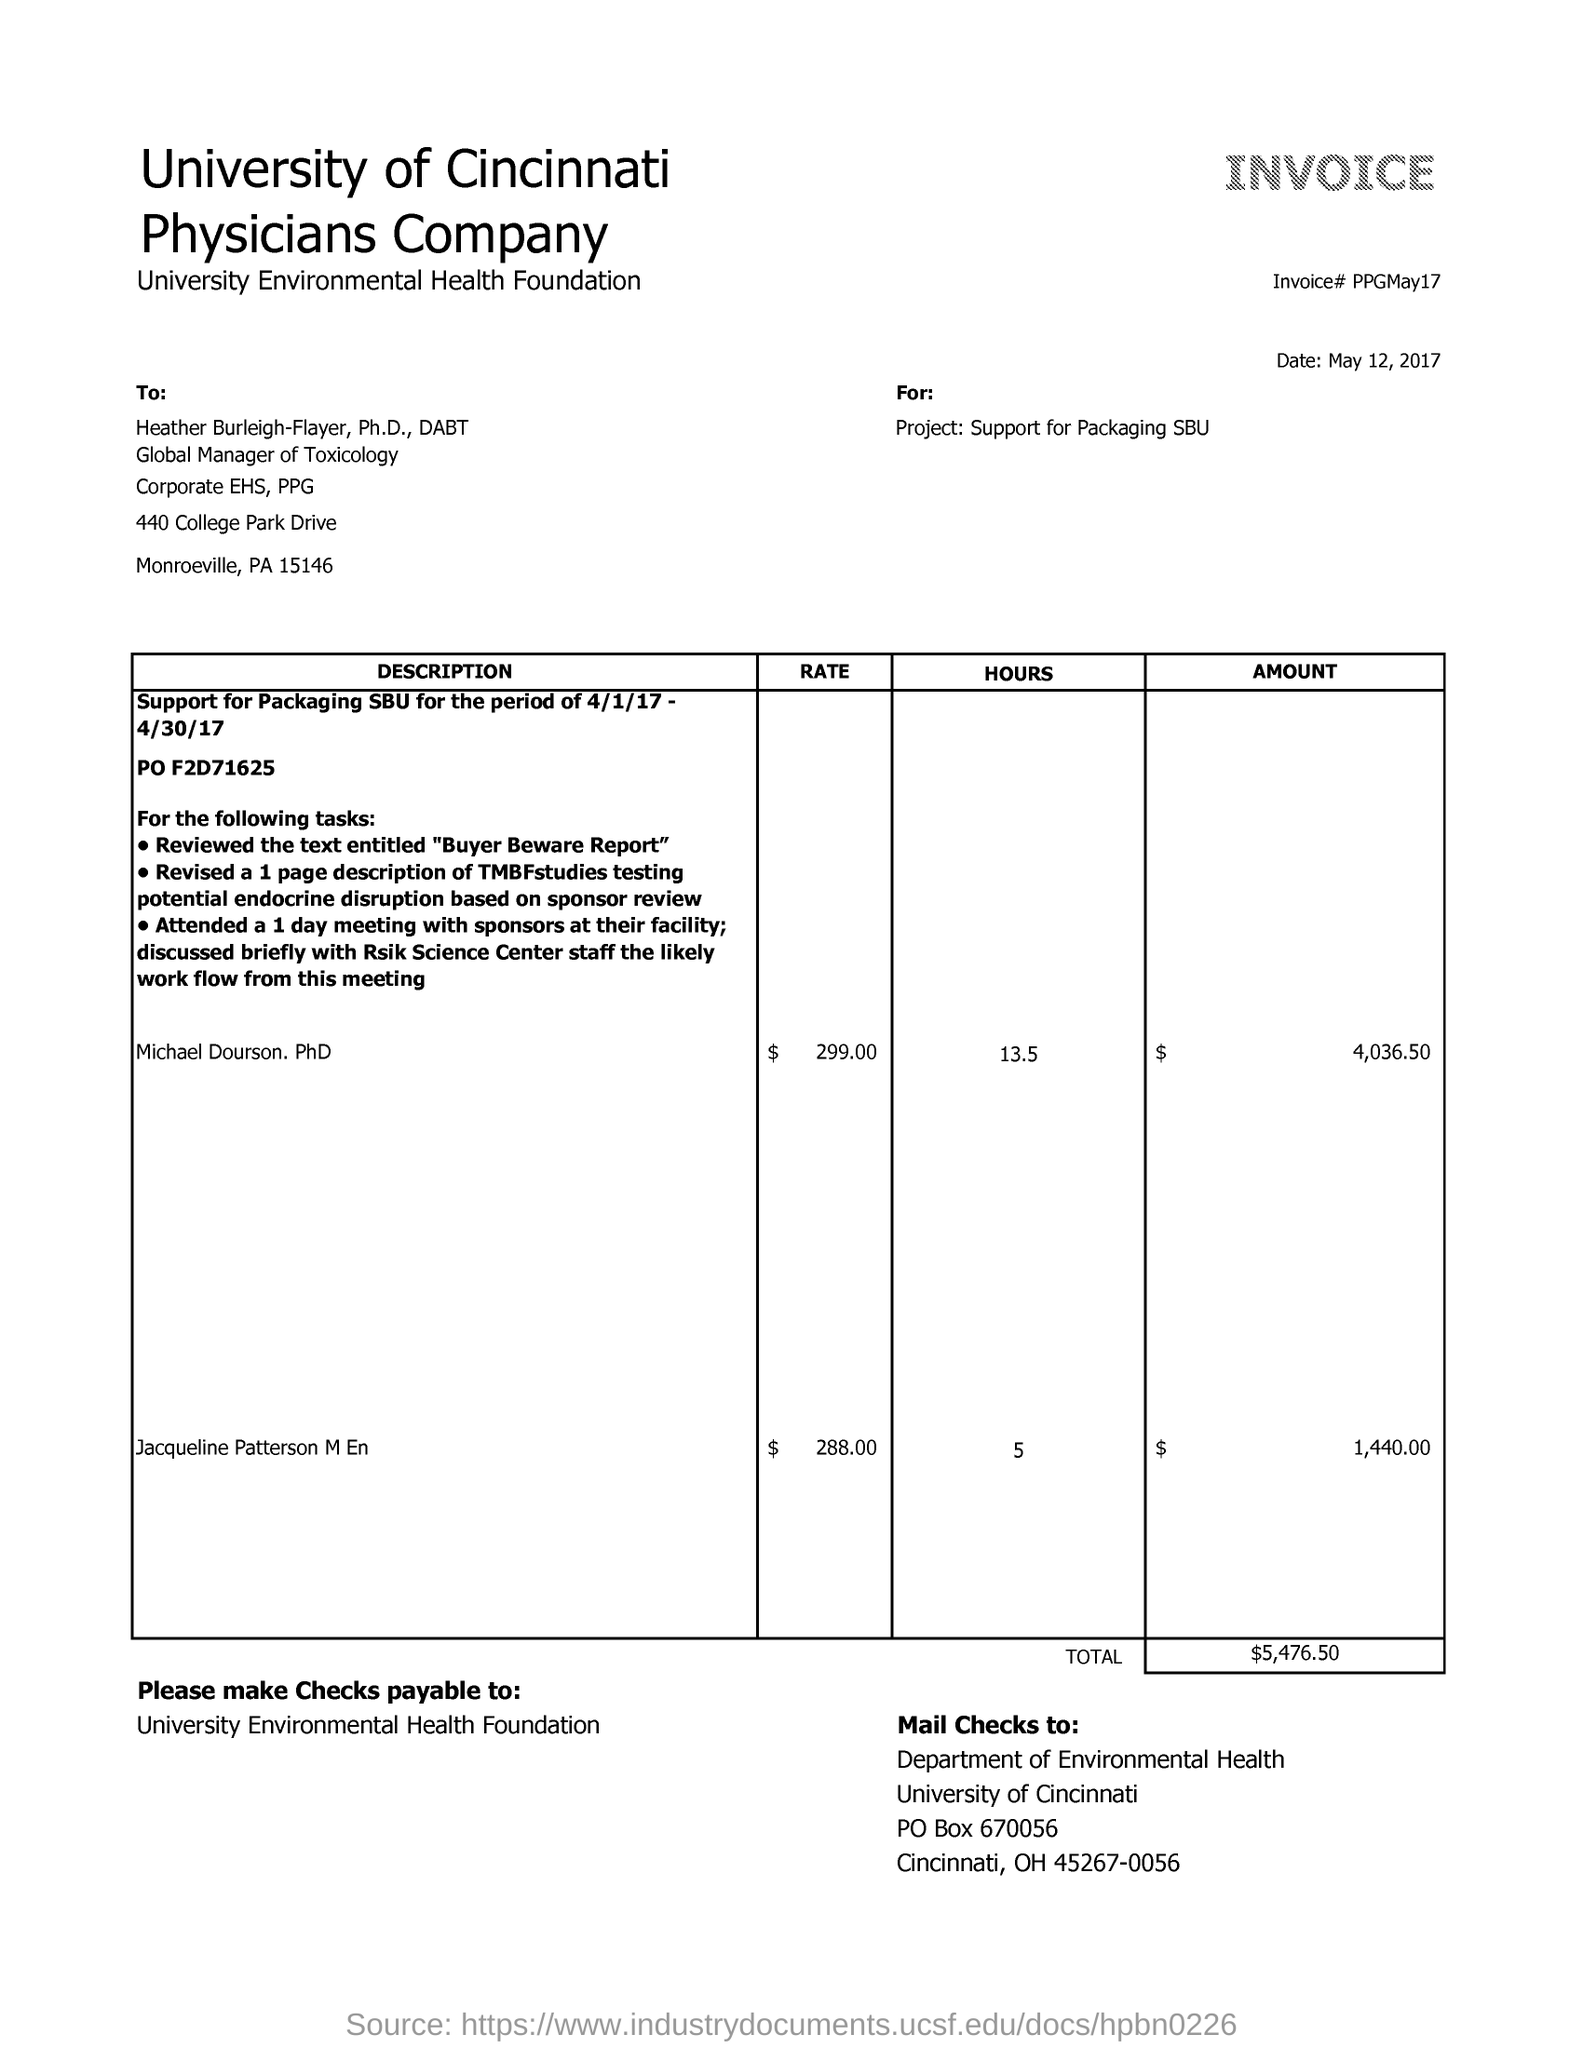What is the date mentioned in the given invoice ?
Ensure brevity in your answer.  May 12,2017. What is the name of the foundation?
Ensure brevity in your answer.  University environmental health foundation. What is the name of the university ?
Keep it short and to the point. University of Cincinnati. To whom the payment of checks to be done ?
Keep it short and to the point. University environmental health foundation. What is the total amount in the given invoice ?
Provide a succinct answer. $5,476.50. 